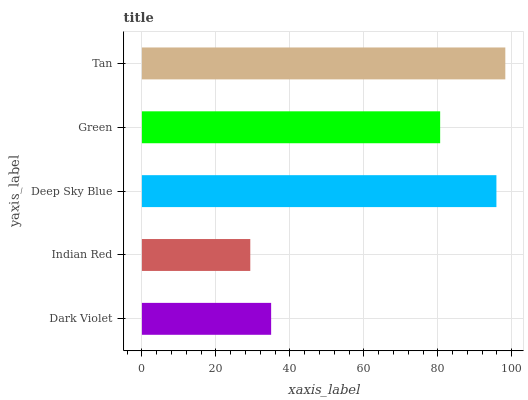Is Indian Red the minimum?
Answer yes or no. Yes. Is Tan the maximum?
Answer yes or no. Yes. Is Deep Sky Blue the minimum?
Answer yes or no. No. Is Deep Sky Blue the maximum?
Answer yes or no. No. Is Deep Sky Blue greater than Indian Red?
Answer yes or no. Yes. Is Indian Red less than Deep Sky Blue?
Answer yes or no. Yes. Is Indian Red greater than Deep Sky Blue?
Answer yes or no. No. Is Deep Sky Blue less than Indian Red?
Answer yes or no. No. Is Green the high median?
Answer yes or no. Yes. Is Green the low median?
Answer yes or no. Yes. Is Deep Sky Blue the high median?
Answer yes or no. No. Is Deep Sky Blue the low median?
Answer yes or no. No. 